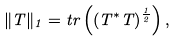Convert formula to latex. <formula><loc_0><loc_0><loc_500><loc_500>\| T \| _ { 1 } = t r \left ( ( T ^ { * } T ) ^ { \frac { 1 } { 2 } } \right ) ,</formula> 